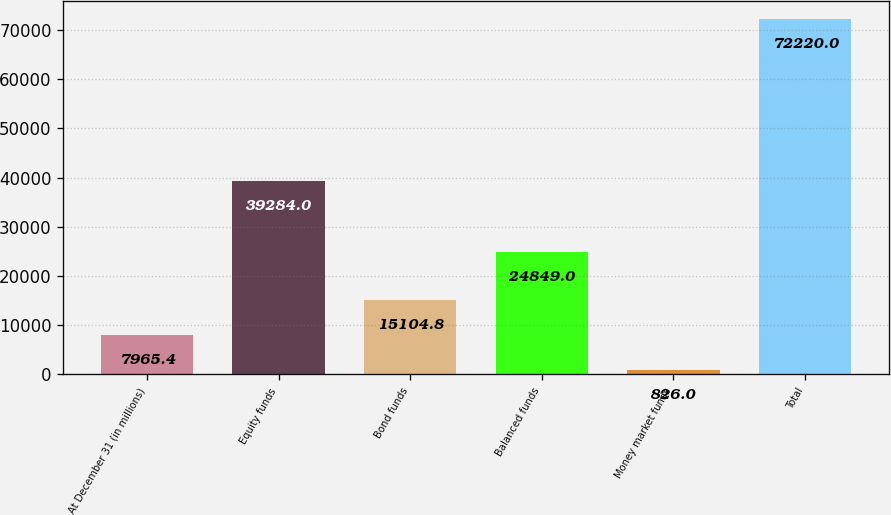Convert chart. <chart><loc_0><loc_0><loc_500><loc_500><bar_chart><fcel>At December 31 (in millions)<fcel>Equity funds<fcel>Bond funds<fcel>Balanced funds<fcel>Money market funds<fcel>Total<nl><fcel>7965.4<fcel>39284<fcel>15104.8<fcel>24849<fcel>826<fcel>72220<nl></chart> 